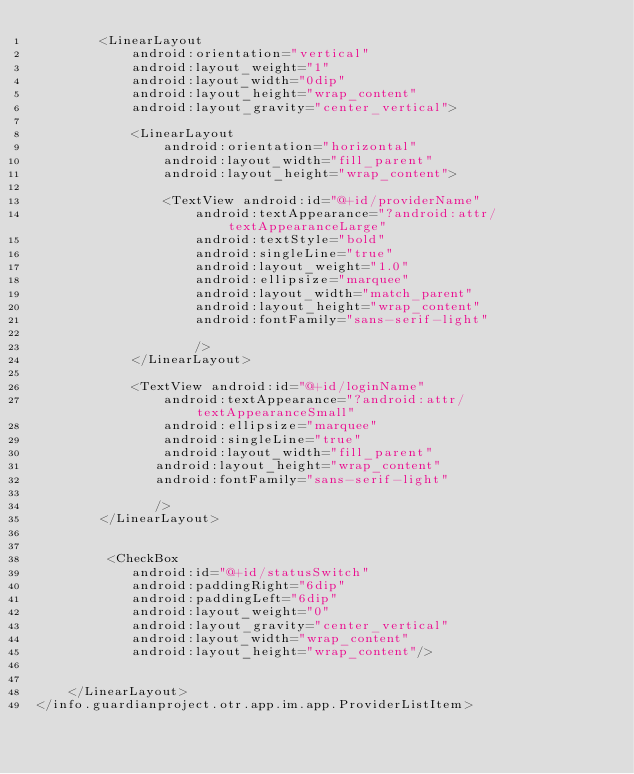Convert code to text. <code><loc_0><loc_0><loc_500><loc_500><_XML_>        <LinearLayout
            android:orientation="vertical"
            android:layout_weight="1"
            android:layout_width="0dip"
            android:layout_height="wrap_content"
            android:layout_gravity="center_vertical">    

            <LinearLayout
                android:orientation="horizontal"
                android:layout_width="fill_parent"
                android:layout_height="wrap_content">

                <TextView android:id="@+id/providerName"
                    android:textAppearance="?android:attr/textAppearanceLarge"
                    android:textStyle="bold"
                    android:singleLine="true"
                    android:layout_weight="1.0"
                    android:ellipsize="marquee"
                    android:layout_width="match_parent"
                    android:layout_height="wrap_content" 
                    android:fontFamily="sans-serif-light"
                    
                    />
            </LinearLayout>

            <TextView android:id="@+id/loginName"
                android:textAppearance="?android:attr/textAppearanceSmall"
                android:ellipsize="marquee"
                android:singleLine="true"
                android:layout_width="fill_parent"
               android:layout_height="wrap_content"
               android:fontFamily="sans-serif-light"
               
               />
        </LinearLayout>
       
             
         <CheckBox
            android:id="@+id/statusSwitch"
            android:paddingRight="6dip"
            android:paddingLeft="6dip"
            android:layout_weight="0"
            android:layout_gravity="center_vertical"
            android:layout_width="wrap_content"
            android:layout_height="wrap_content"/>
         
         
    </LinearLayout>
</info.guardianproject.otr.app.im.app.ProviderListItem>
</code> 